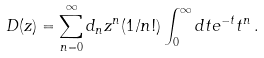<formula> <loc_0><loc_0><loc_500><loc_500>D ( z ) = \sum _ { n = 0 } ^ { \infty } d _ { n } z ^ { n } ( 1 / n ! ) \int _ { 0 } ^ { \infty } d t e ^ { - t } t ^ { n } \, .</formula> 